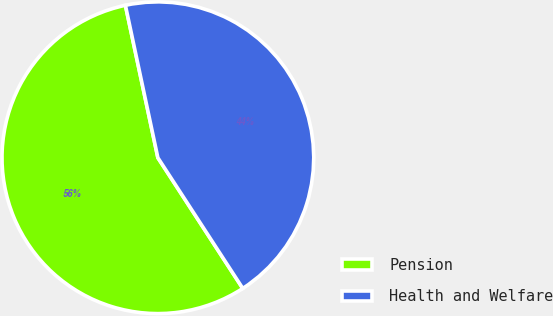Convert chart. <chart><loc_0><loc_0><loc_500><loc_500><pie_chart><fcel>Pension<fcel>Health and Welfare<nl><fcel>55.83%<fcel>44.17%<nl></chart> 